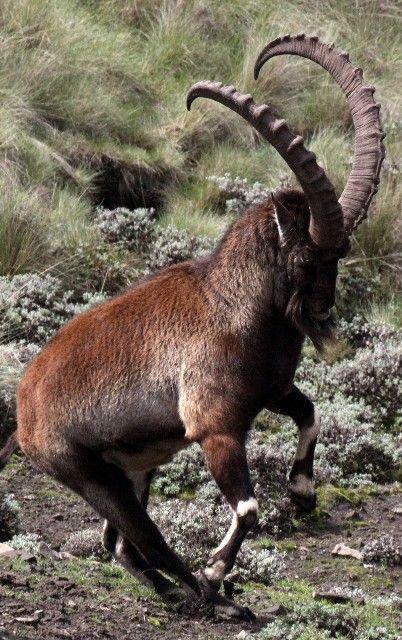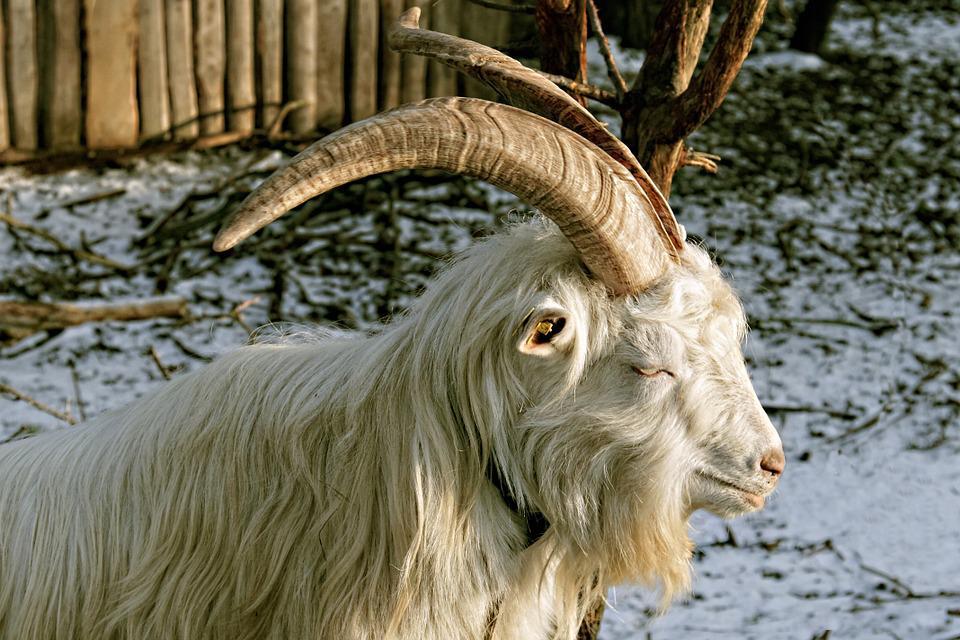The first image is the image on the left, the second image is the image on the right. For the images shown, is this caption "Horned rams in the  pair of images are facing toward each other." true? Answer yes or no. No. 